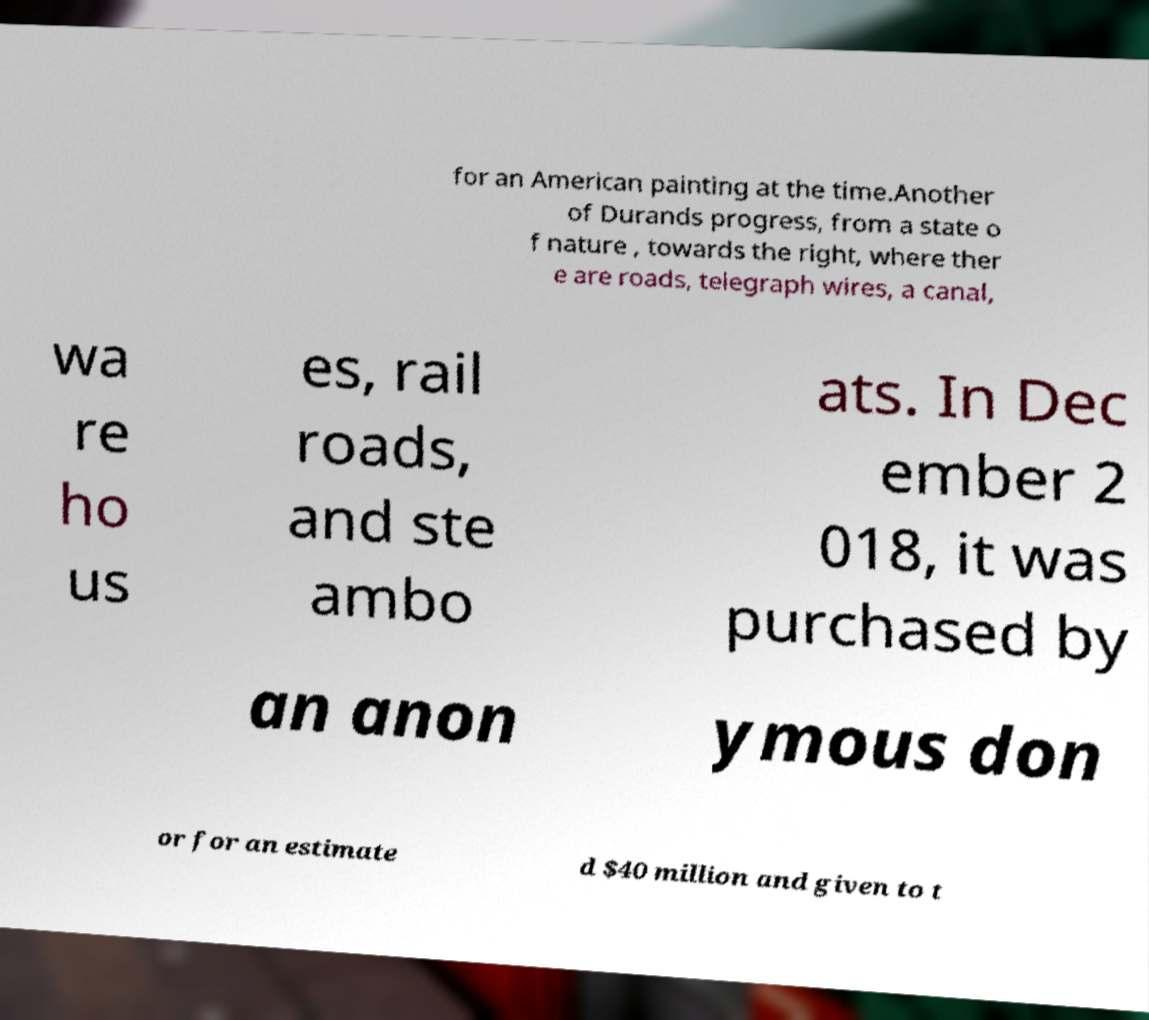Can you read and provide the text displayed in the image?This photo seems to have some interesting text. Can you extract and type it out for me? for an American painting at the time.Another of Durands progress, from a state o f nature , towards the right, where ther e are roads, telegraph wires, a canal, wa re ho us es, rail roads, and ste ambo ats. In Dec ember 2 018, it was purchased by an anon ymous don or for an estimate d $40 million and given to t 